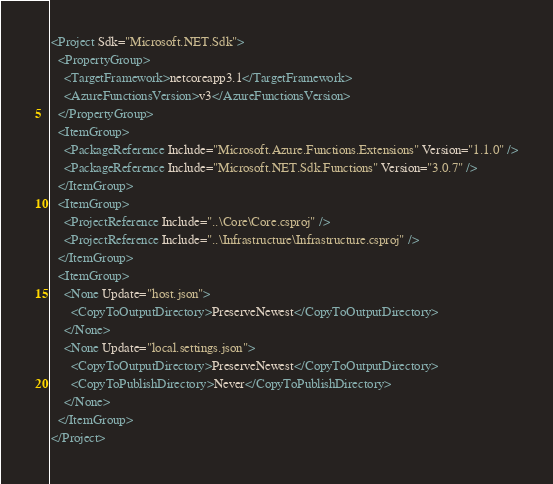<code> <loc_0><loc_0><loc_500><loc_500><_XML_><Project Sdk="Microsoft.NET.Sdk">
  <PropertyGroup>
    <TargetFramework>netcoreapp3.1</TargetFramework>
    <AzureFunctionsVersion>v3</AzureFunctionsVersion>
  </PropertyGroup>
  <ItemGroup>
    <PackageReference Include="Microsoft.Azure.Functions.Extensions" Version="1.1.0" />
    <PackageReference Include="Microsoft.NET.Sdk.Functions" Version="3.0.7" />
  </ItemGroup>
  <ItemGroup>
    <ProjectReference Include="..\Core\Core.csproj" />
    <ProjectReference Include="..\Infrastructure\Infrastructure.csproj" />
  </ItemGroup>
  <ItemGroup>
    <None Update="host.json">
      <CopyToOutputDirectory>PreserveNewest</CopyToOutputDirectory>
    </None>
    <None Update="local.settings.json">
      <CopyToOutputDirectory>PreserveNewest</CopyToOutputDirectory>
      <CopyToPublishDirectory>Never</CopyToPublishDirectory>
    </None>
  </ItemGroup>
</Project>
</code> 